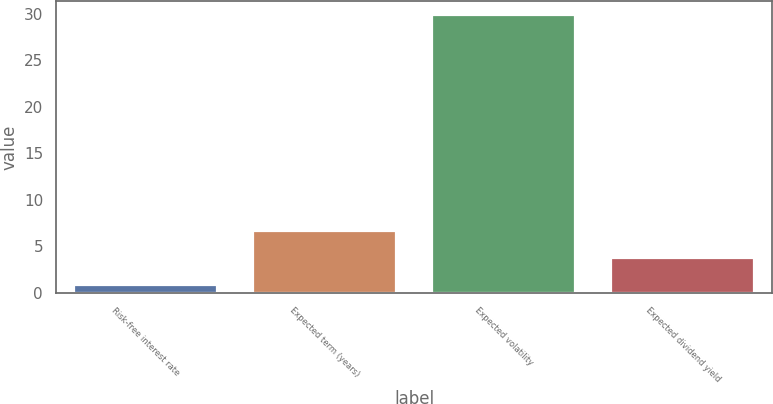<chart> <loc_0><loc_0><loc_500><loc_500><bar_chart><fcel>Risk-free interest rate<fcel>Expected term (years)<fcel>Expected volatility<fcel>Expected dividend yield<nl><fcel>0.8<fcel>6.62<fcel>29.9<fcel>3.71<nl></chart> 